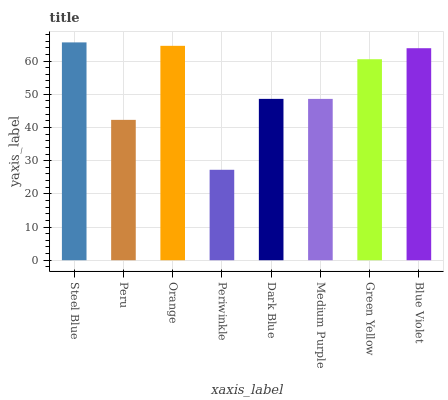Is Periwinkle the minimum?
Answer yes or no. Yes. Is Steel Blue the maximum?
Answer yes or no. Yes. Is Peru the minimum?
Answer yes or no. No. Is Peru the maximum?
Answer yes or no. No. Is Steel Blue greater than Peru?
Answer yes or no. Yes. Is Peru less than Steel Blue?
Answer yes or no. Yes. Is Peru greater than Steel Blue?
Answer yes or no. No. Is Steel Blue less than Peru?
Answer yes or no. No. Is Green Yellow the high median?
Answer yes or no. Yes. Is Dark Blue the low median?
Answer yes or no. Yes. Is Orange the high median?
Answer yes or no. No. Is Blue Violet the low median?
Answer yes or no. No. 